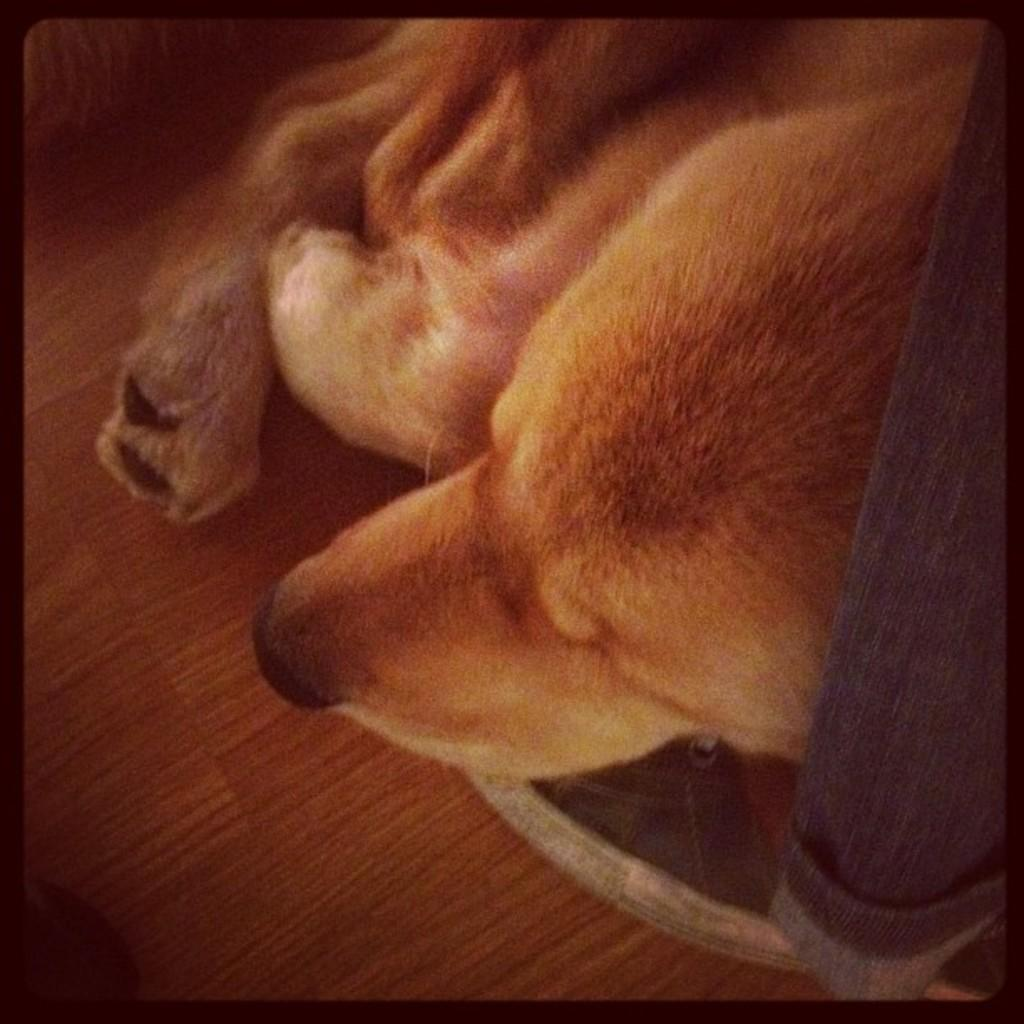What can be observed about the image's appearance? The image is edited. What animal is present in the image? There is a dog in the image. What position is the dog in? The dog is laying on the floor. What type of rock is being used as a prop in the image? There is no rock present in the image; it features a dog laying on the floor. What class is being taught in the image? There is no class being taught in the image; it features a dog laying on the floor. 